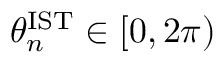Convert formula to latex. <formula><loc_0><loc_0><loc_500><loc_500>\theta _ { n } ^ { I S T } \in [ 0 , 2 \pi )</formula> 